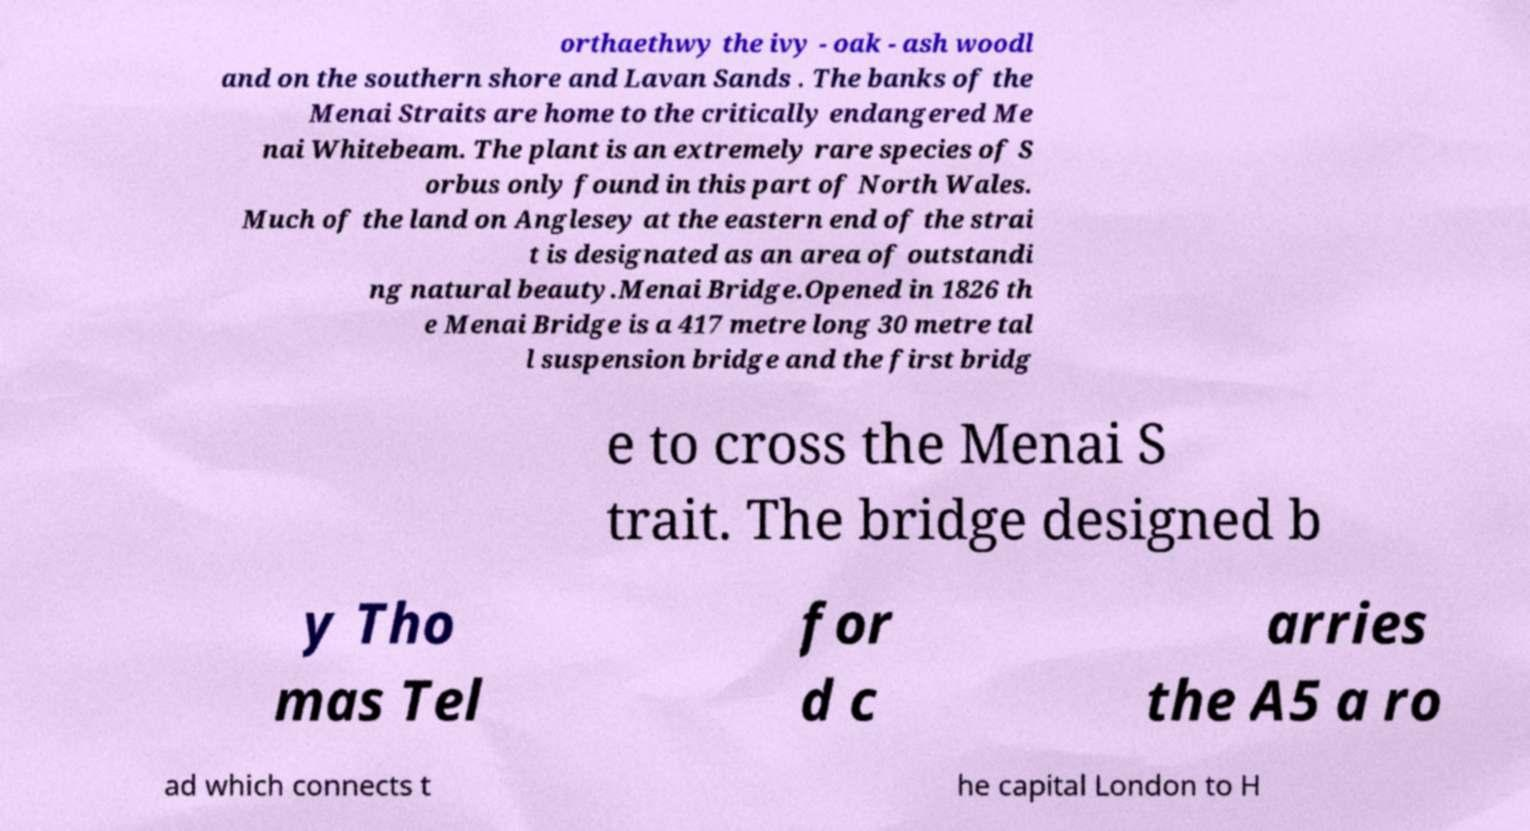I need the written content from this picture converted into text. Can you do that? orthaethwy the ivy - oak - ash woodl and on the southern shore and Lavan Sands . The banks of the Menai Straits are home to the critically endangered Me nai Whitebeam. The plant is an extremely rare species of S orbus only found in this part of North Wales. Much of the land on Anglesey at the eastern end of the strai t is designated as an area of outstandi ng natural beauty.Menai Bridge.Opened in 1826 th e Menai Bridge is a 417 metre long 30 metre tal l suspension bridge and the first bridg e to cross the Menai S trait. The bridge designed b y Tho mas Tel for d c arries the A5 a ro ad which connects t he capital London to H 